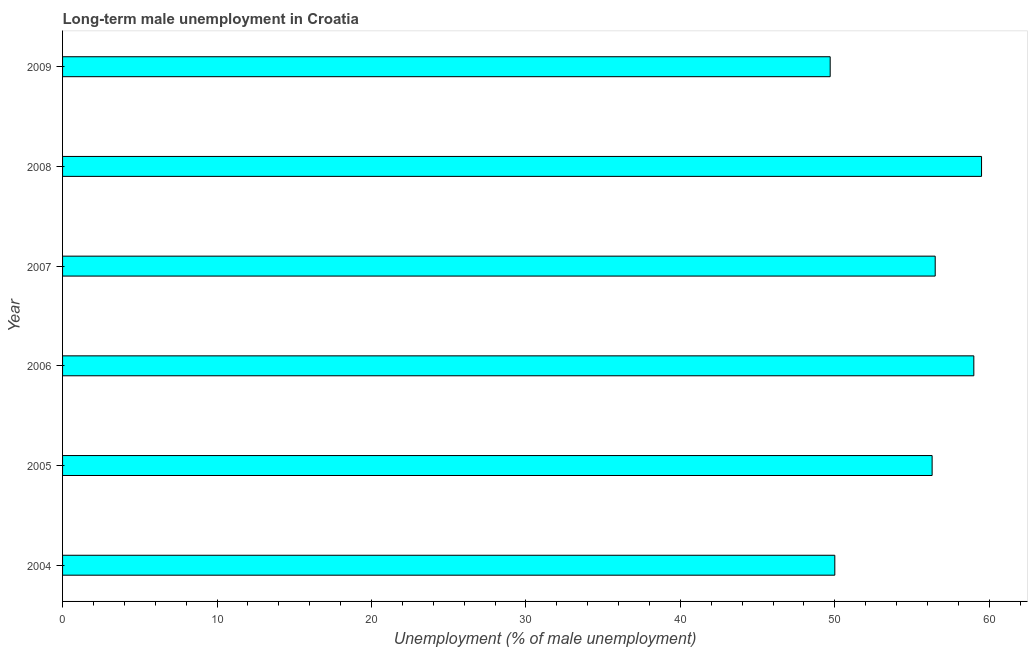Does the graph contain grids?
Keep it short and to the point. No. What is the title of the graph?
Keep it short and to the point. Long-term male unemployment in Croatia. What is the label or title of the X-axis?
Offer a very short reply. Unemployment (% of male unemployment). What is the label or title of the Y-axis?
Offer a very short reply. Year. What is the long-term male unemployment in 2008?
Offer a terse response. 59.5. Across all years, what is the maximum long-term male unemployment?
Your response must be concise. 59.5. Across all years, what is the minimum long-term male unemployment?
Offer a terse response. 49.7. In which year was the long-term male unemployment maximum?
Give a very brief answer. 2008. In which year was the long-term male unemployment minimum?
Keep it short and to the point. 2009. What is the sum of the long-term male unemployment?
Keep it short and to the point. 331. What is the difference between the long-term male unemployment in 2007 and 2008?
Offer a terse response. -3. What is the average long-term male unemployment per year?
Ensure brevity in your answer.  55.17. What is the median long-term male unemployment?
Your answer should be compact. 56.4. Do a majority of the years between 2006 and 2007 (inclusive) have long-term male unemployment greater than 46 %?
Ensure brevity in your answer.  Yes. What is the ratio of the long-term male unemployment in 2008 to that in 2009?
Make the answer very short. 1.2. Is the long-term male unemployment in 2006 less than that in 2008?
Keep it short and to the point. Yes. Is the difference between the long-term male unemployment in 2004 and 2007 greater than the difference between any two years?
Offer a terse response. No. What is the difference between the highest and the second highest long-term male unemployment?
Make the answer very short. 0.5. How many bars are there?
Offer a very short reply. 6. Are all the bars in the graph horizontal?
Make the answer very short. Yes. What is the difference between two consecutive major ticks on the X-axis?
Make the answer very short. 10. Are the values on the major ticks of X-axis written in scientific E-notation?
Provide a short and direct response. No. What is the Unemployment (% of male unemployment) of 2004?
Give a very brief answer. 50. What is the Unemployment (% of male unemployment) in 2005?
Your answer should be very brief. 56.3. What is the Unemployment (% of male unemployment) of 2007?
Your answer should be compact. 56.5. What is the Unemployment (% of male unemployment) in 2008?
Keep it short and to the point. 59.5. What is the Unemployment (% of male unemployment) in 2009?
Provide a succinct answer. 49.7. What is the difference between the Unemployment (% of male unemployment) in 2004 and 2005?
Offer a terse response. -6.3. What is the difference between the Unemployment (% of male unemployment) in 2004 and 2007?
Keep it short and to the point. -6.5. What is the difference between the Unemployment (% of male unemployment) in 2005 and 2007?
Make the answer very short. -0.2. What is the difference between the Unemployment (% of male unemployment) in 2005 and 2008?
Your answer should be very brief. -3.2. What is the difference between the Unemployment (% of male unemployment) in 2006 and 2007?
Provide a succinct answer. 2.5. What is the difference between the Unemployment (% of male unemployment) in 2007 and 2008?
Ensure brevity in your answer.  -3. What is the difference between the Unemployment (% of male unemployment) in 2007 and 2009?
Your response must be concise. 6.8. What is the difference between the Unemployment (% of male unemployment) in 2008 and 2009?
Give a very brief answer. 9.8. What is the ratio of the Unemployment (% of male unemployment) in 2004 to that in 2005?
Give a very brief answer. 0.89. What is the ratio of the Unemployment (% of male unemployment) in 2004 to that in 2006?
Your answer should be compact. 0.85. What is the ratio of the Unemployment (% of male unemployment) in 2004 to that in 2007?
Provide a succinct answer. 0.89. What is the ratio of the Unemployment (% of male unemployment) in 2004 to that in 2008?
Provide a succinct answer. 0.84. What is the ratio of the Unemployment (% of male unemployment) in 2005 to that in 2006?
Provide a succinct answer. 0.95. What is the ratio of the Unemployment (% of male unemployment) in 2005 to that in 2008?
Keep it short and to the point. 0.95. What is the ratio of the Unemployment (% of male unemployment) in 2005 to that in 2009?
Provide a succinct answer. 1.13. What is the ratio of the Unemployment (% of male unemployment) in 2006 to that in 2007?
Provide a short and direct response. 1.04. What is the ratio of the Unemployment (% of male unemployment) in 2006 to that in 2009?
Your answer should be compact. 1.19. What is the ratio of the Unemployment (% of male unemployment) in 2007 to that in 2009?
Provide a short and direct response. 1.14. What is the ratio of the Unemployment (% of male unemployment) in 2008 to that in 2009?
Provide a succinct answer. 1.2. 